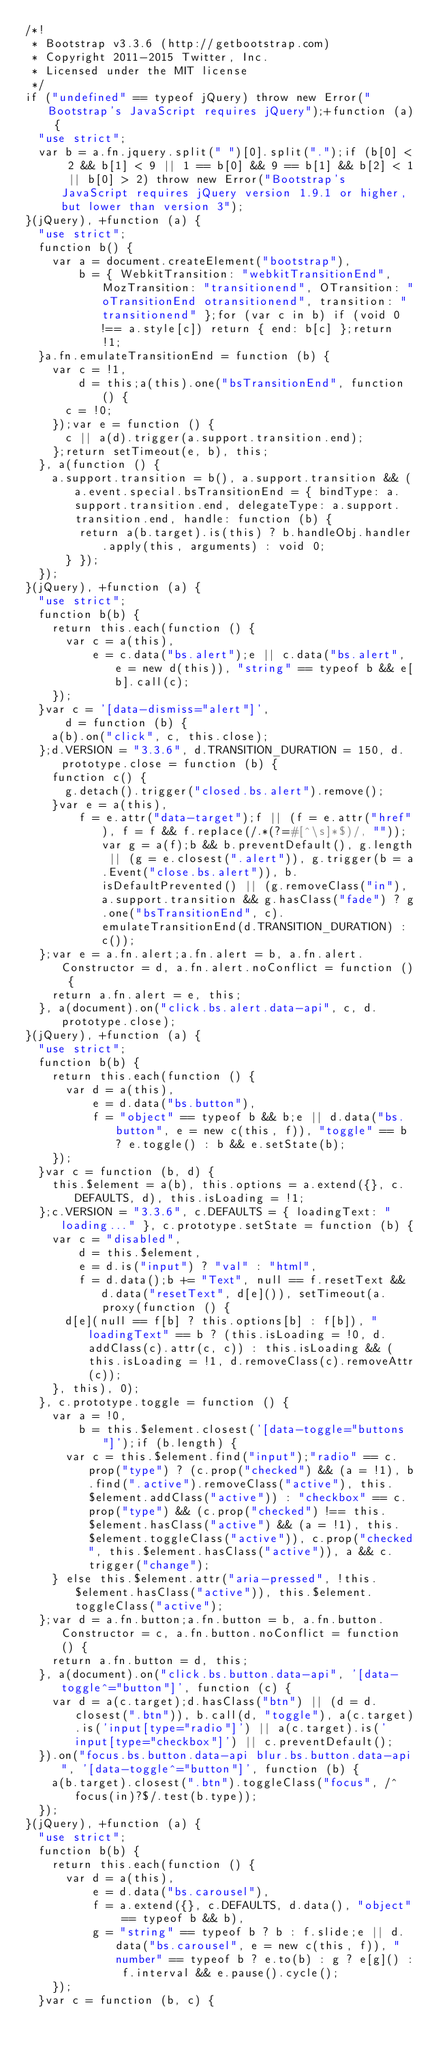<code> <loc_0><loc_0><loc_500><loc_500><_JavaScript_>/*!
 * Bootstrap v3.3.6 (http://getbootstrap.com)
 * Copyright 2011-2015 Twitter, Inc.
 * Licensed under the MIT license
 */
if ("undefined" == typeof jQuery) throw new Error("Bootstrap's JavaScript requires jQuery");+function (a) {
  "use strict";
  var b = a.fn.jquery.split(" ")[0].split(".");if (b[0] < 2 && b[1] < 9 || 1 == b[0] && 9 == b[1] && b[2] < 1 || b[0] > 2) throw new Error("Bootstrap's JavaScript requires jQuery version 1.9.1 or higher, but lower than version 3");
}(jQuery), +function (a) {
  "use strict";
  function b() {
    var a = document.createElement("bootstrap"),
        b = { WebkitTransition: "webkitTransitionEnd", MozTransition: "transitionend", OTransition: "oTransitionEnd otransitionend", transition: "transitionend" };for (var c in b) if (void 0 !== a.style[c]) return { end: b[c] };return !1;
  }a.fn.emulateTransitionEnd = function (b) {
    var c = !1,
        d = this;a(this).one("bsTransitionEnd", function () {
      c = !0;
    });var e = function () {
      c || a(d).trigger(a.support.transition.end);
    };return setTimeout(e, b), this;
  }, a(function () {
    a.support.transition = b(), a.support.transition && (a.event.special.bsTransitionEnd = { bindType: a.support.transition.end, delegateType: a.support.transition.end, handle: function (b) {
        return a(b.target).is(this) ? b.handleObj.handler.apply(this, arguments) : void 0;
      } });
  });
}(jQuery), +function (a) {
  "use strict";
  function b(b) {
    return this.each(function () {
      var c = a(this),
          e = c.data("bs.alert");e || c.data("bs.alert", e = new d(this)), "string" == typeof b && e[b].call(c);
    });
  }var c = '[data-dismiss="alert"]',
      d = function (b) {
    a(b).on("click", c, this.close);
  };d.VERSION = "3.3.6", d.TRANSITION_DURATION = 150, d.prototype.close = function (b) {
    function c() {
      g.detach().trigger("closed.bs.alert").remove();
    }var e = a(this),
        f = e.attr("data-target");f || (f = e.attr("href"), f = f && f.replace(/.*(?=#[^\s]*$)/, ""));var g = a(f);b && b.preventDefault(), g.length || (g = e.closest(".alert")), g.trigger(b = a.Event("close.bs.alert")), b.isDefaultPrevented() || (g.removeClass("in"), a.support.transition && g.hasClass("fade") ? g.one("bsTransitionEnd", c).emulateTransitionEnd(d.TRANSITION_DURATION) : c());
  };var e = a.fn.alert;a.fn.alert = b, a.fn.alert.Constructor = d, a.fn.alert.noConflict = function () {
    return a.fn.alert = e, this;
  }, a(document).on("click.bs.alert.data-api", c, d.prototype.close);
}(jQuery), +function (a) {
  "use strict";
  function b(b) {
    return this.each(function () {
      var d = a(this),
          e = d.data("bs.button"),
          f = "object" == typeof b && b;e || d.data("bs.button", e = new c(this, f)), "toggle" == b ? e.toggle() : b && e.setState(b);
    });
  }var c = function (b, d) {
    this.$element = a(b), this.options = a.extend({}, c.DEFAULTS, d), this.isLoading = !1;
  };c.VERSION = "3.3.6", c.DEFAULTS = { loadingText: "loading..." }, c.prototype.setState = function (b) {
    var c = "disabled",
        d = this.$element,
        e = d.is("input") ? "val" : "html",
        f = d.data();b += "Text", null == f.resetText && d.data("resetText", d[e]()), setTimeout(a.proxy(function () {
      d[e](null == f[b] ? this.options[b] : f[b]), "loadingText" == b ? (this.isLoading = !0, d.addClass(c).attr(c, c)) : this.isLoading && (this.isLoading = !1, d.removeClass(c).removeAttr(c));
    }, this), 0);
  }, c.prototype.toggle = function () {
    var a = !0,
        b = this.$element.closest('[data-toggle="buttons"]');if (b.length) {
      var c = this.$element.find("input");"radio" == c.prop("type") ? (c.prop("checked") && (a = !1), b.find(".active").removeClass("active"), this.$element.addClass("active")) : "checkbox" == c.prop("type") && (c.prop("checked") !== this.$element.hasClass("active") && (a = !1), this.$element.toggleClass("active")), c.prop("checked", this.$element.hasClass("active")), a && c.trigger("change");
    } else this.$element.attr("aria-pressed", !this.$element.hasClass("active")), this.$element.toggleClass("active");
  };var d = a.fn.button;a.fn.button = b, a.fn.button.Constructor = c, a.fn.button.noConflict = function () {
    return a.fn.button = d, this;
  }, a(document).on("click.bs.button.data-api", '[data-toggle^="button"]', function (c) {
    var d = a(c.target);d.hasClass("btn") || (d = d.closest(".btn")), b.call(d, "toggle"), a(c.target).is('input[type="radio"]') || a(c.target).is('input[type="checkbox"]') || c.preventDefault();
  }).on("focus.bs.button.data-api blur.bs.button.data-api", '[data-toggle^="button"]', function (b) {
    a(b.target).closest(".btn").toggleClass("focus", /^focus(in)?$/.test(b.type));
  });
}(jQuery), +function (a) {
  "use strict";
  function b(b) {
    return this.each(function () {
      var d = a(this),
          e = d.data("bs.carousel"),
          f = a.extend({}, c.DEFAULTS, d.data(), "object" == typeof b && b),
          g = "string" == typeof b ? b : f.slide;e || d.data("bs.carousel", e = new c(this, f)), "number" == typeof b ? e.to(b) : g ? e[g]() : f.interval && e.pause().cycle();
    });
  }var c = function (b, c) {</code> 